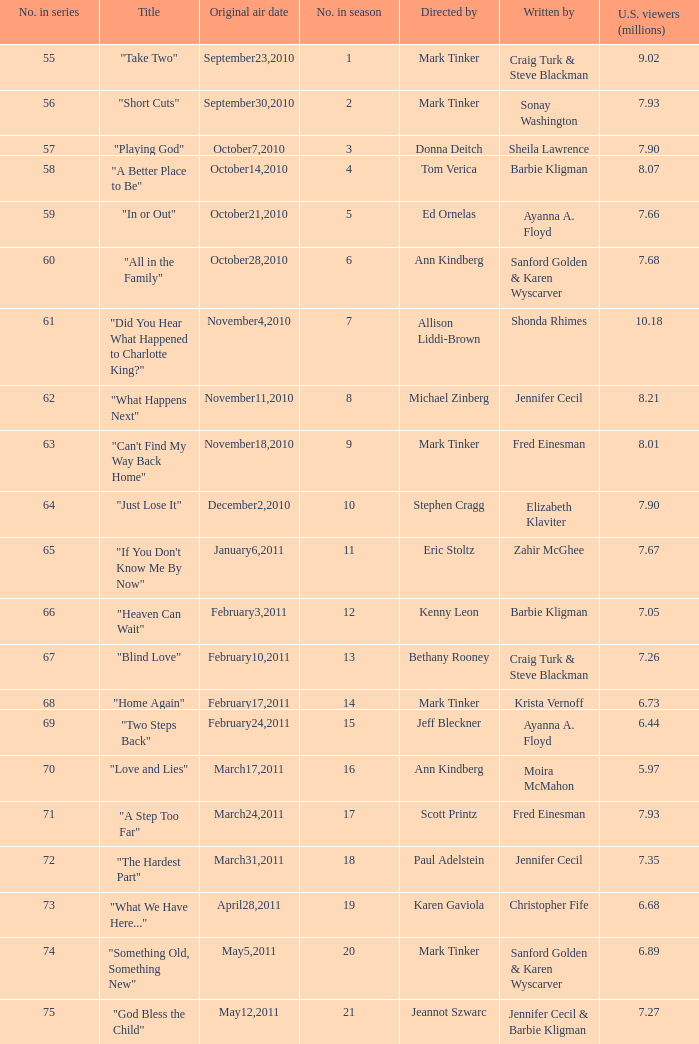What number episode in the season was directed by Paul Adelstein?  18.0. 